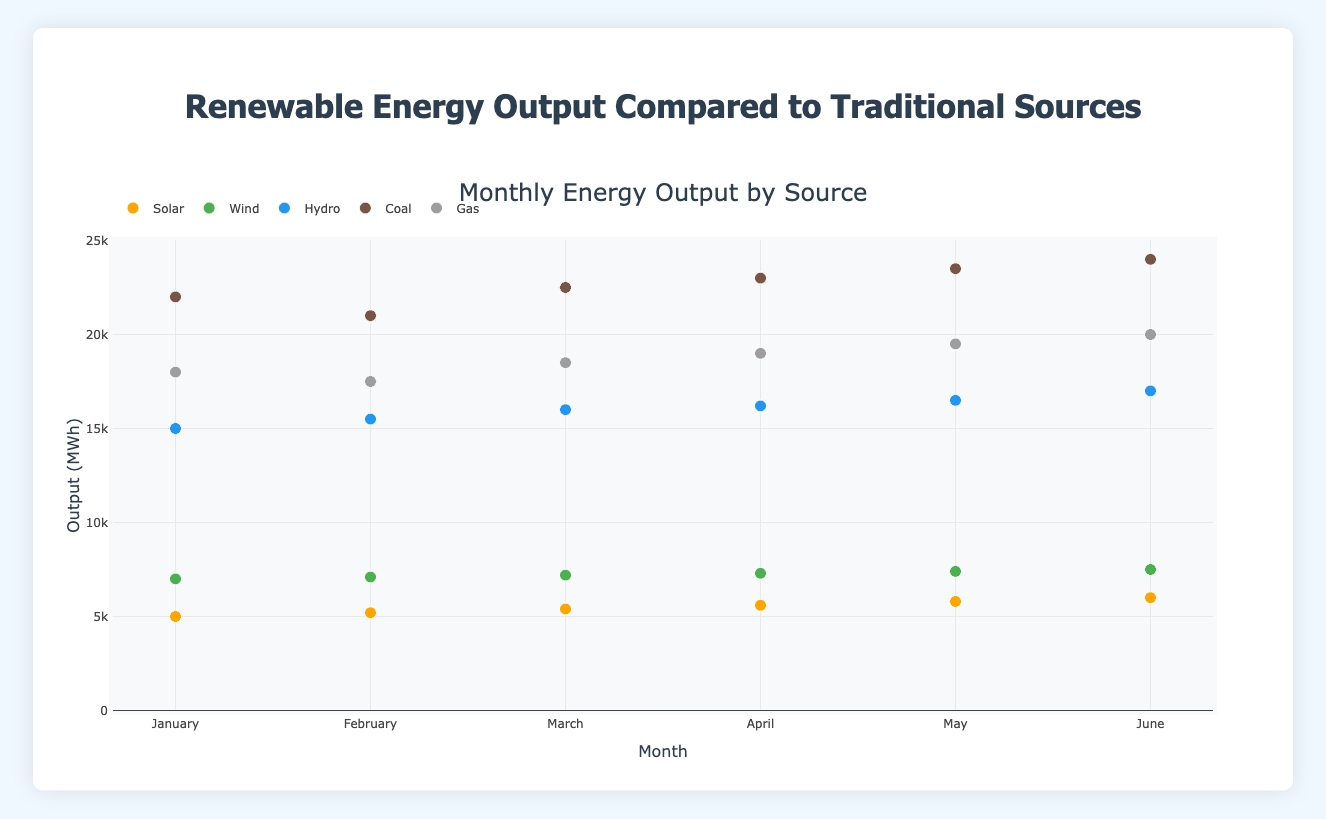What is the title of the plot? The plot has a title at the top that reads "Monthly Energy Output by Source."
Answer: Monthly Energy Output by Source What are the sources of energy shown in the plot? Each point on the scatter plot is labeled by color, representing different energy sources: Solar, Wind, Hydro, Coal, and Gas.
Answer: Solar, Wind, Hydro, Coal, Gas Which month has the highest output for Hydro energy, and what is that output? By examining the y-axis values for Hydro energy data points (blue markers) across all months, June shows the highest output at 17000 MWh.
Answer: June, 17000 MWh How does the output of Solar energy change from January to June? Observing Solar energy data points (orange markers) from January to June, the output increases sequentially from 5000 MWh in January to 6000 MWh in June.
Answer: It increases from 5000 MWh to 6000 MWh Which traditional energy source had the lowest output in February, and what was the amount? Among the traditional sources (Coal and Gas), the output points for February show that Gas had the lowest output at 17500 MWh.
Answer: Gas, 17500 MWh Compare the general trends of Solar and Coal outputs over the months. Which one shows a steeper increase? Solar output rises gradually from 5000 MWh in January to 6000 MWh in June, whereas Coal output increases from 22000 MWh to 24000 MWh. By comparing the slope, Coal shows a steeper increase overall.
Answer: Coal What is the approximate average output of Wind energy from January to June? Summing up Wind energy outputs from January (7000), February (7100), March (7200), April (7300), May (7400), and June (7500) gives 43500. Dividing by 6 months gives 7250 MWh.
Answer: 7250 MWh By how much is May's Coal output higher than January's? Subtracting January's Coal output of 22000 MWh from May's Coal output of 23500 MWh shows an increase of 1500 MWh.
Answer: 1500 MWh 